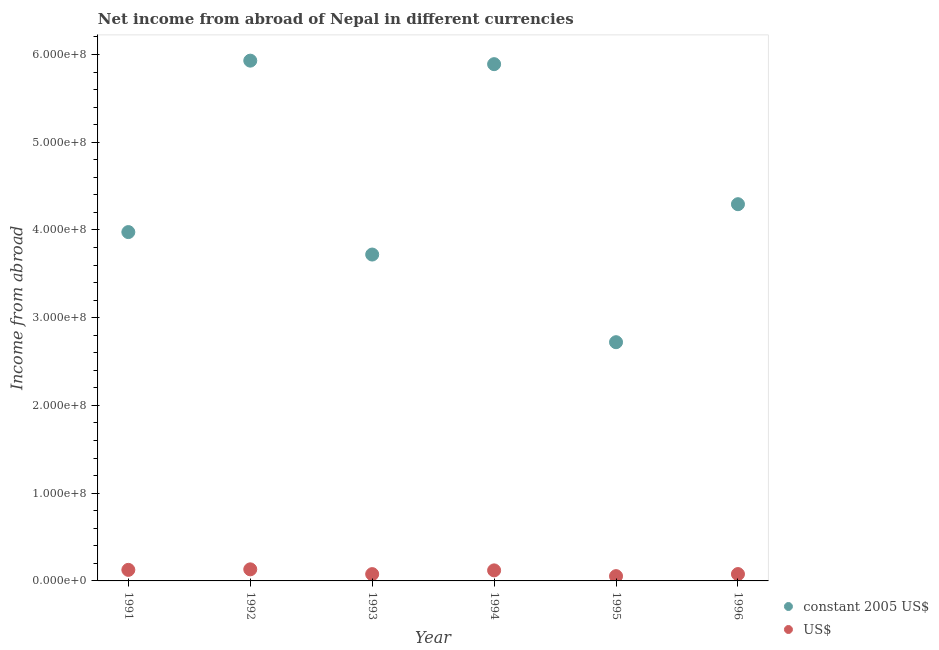How many different coloured dotlines are there?
Offer a terse response. 2. Is the number of dotlines equal to the number of legend labels?
Your response must be concise. Yes. What is the income from abroad in constant 2005 us$ in 1991?
Provide a short and direct response. 3.98e+08. Across all years, what is the maximum income from abroad in us$?
Provide a short and direct response. 1.32e+07. Across all years, what is the minimum income from abroad in constant 2005 us$?
Your response must be concise. 2.72e+08. In which year was the income from abroad in constant 2005 us$ maximum?
Keep it short and to the point. 1992. In which year was the income from abroad in constant 2005 us$ minimum?
Your answer should be compact. 1995. What is the total income from abroad in constant 2005 us$ in the graph?
Provide a succinct answer. 2.65e+09. What is the difference between the income from abroad in us$ in 1991 and that in 1992?
Offer a very short reply. -6.13e+05. What is the difference between the income from abroad in constant 2005 us$ in 1992 and the income from abroad in us$ in 1991?
Offer a terse response. 5.80e+08. What is the average income from abroad in constant 2005 us$ per year?
Keep it short and to the point. 4.42e+08. In the year 1996, what is the difference between the income from abroad in us$ and income from abroad in constant 2005 us$?
Ensure brevity in your answer.  -4.22e+08. In how many years, is the income from abroad in us$ greater than 600000000 units?
Your response must be concise. 0. What is the ratio of the income from abroad in us$ in 1992 to that in 1994?
Your response must be concise. 1.1. Is the income from abroad in us$ in 1993 less than that in 1995?
Give a very brief answer. No. Is the difference between the income from abroad in constant 2005 us$ in 1992 and 1996 greater than the difference between the income from abroad in us$ in 1992 and 1996?
Provide a short and direct response. Yes. What is the difference between the highest and the lowest income from abroad in constant 2005 us$?
Provide a short and direct response. 3.21e+08. Is the income from abroad in us$ strictly greater than the income from abroad in constant 2005 us$ over the years?
Your answer should be compact. No. Is the income from abroad in constant 2005 us$ strictly less than the income from abroad in us$ over the years?
Make the answer very short. No. Does the graph contain grids?
Your answer should be compact. No. How many legend labels are there?
Offer a very short reply. 2. What is the title of the graph?
Ensure brevity in your answer.  Net income from abroad of Nepal in different currencies. Does "Males" appear as one of the legend labels in the graph?
Your answer should be very brief. No. What is the label or title of the Y-axis?
Your answer should be very brief. Income from abroad. What is the Income from abroad of constant 2005 US$ in 1991?
Provide a short and direct response. 3.98e+08. What is the Income from abroad of US$ in 1991?
Make the answer very short. 1.26e+07. What is the Income from abroad of constant 2005 US$ in 1992?
Provide a short and direct response. 5.93e+08. What is the Income from abroad of US$ in 1992?
Your answer should be very brief. 1.32e+07. What is the Income from abroad of constant 2005 US$ in 1993?
Provide a succinct answer. 3.72e+08. What is the Income from abroad of US$ in 1993?
Offer a very short reply. 7.75e+06. What is the Income from abroad in constant 2005 US$ in 1994?
Keep it short and to the point. 5.89e+08. What is the Income from abroad in US$ in 1994?
Offer a terse response. 1.20e+07. What is the Income from abroad of constant 2005 US$ in 1995?
Your answer should be compact. 2.72e+08. What is the Income from abroad of US$ in 1995?
Keep it short and to the point. 5.46e+06. What is the Income from abroad of constant 2005 US$ in 1996?
Give a very brief answer. 4.29e+08. What is the Income from abroad of US$ in 1996?
Provide a short and direct response. 7.80e+06. Across all years, what is the maximum Income from abroad of constant 2005 US$?
Keep it short and to the point. 5.93e+08. Across all years, what is the maximum Income from abroad in US$?
Your answer should be very brief. 1.32e+07. Across all years, what is the minimum Income from abroad of constant 2005 US$?
Your answer should be very brief. 2.72e+08. Across all years, what is the minimum Income from abroad of US$?
Make the answer very short. 5.46e+06. What is the total Income from abroad of constant 2005 US$ in the graph?
Keep it short and to the point. 2.65e+09. What is the total Income from abroad of US$ in the graph?
Make the answer very short. 5.88e+07. What is the difference between the Income from abroad of constant 2005 US$ in 1991 and that in 1992?
Your answer should be very brief. -1.95e+08. What is the difference between the Income from abroad of US$ in 1991 and that in 1992?
Ensure brevity in your answer.  -6.13e+05. What is the difference between the Income from abroad in constant 2005 US$ in 1991 and that in 1993?
Your answer should be compact. 2.56e+07. What is the difference between the Income from abroad in US$ in 1991 and that in 1993?
Make the answer very short. 4.84e+06. What is the difference between the Income from abroad of constant 2005 US$ in 1991 and that in 1994?
Make the answer very short. -1.91e+08. What is the difference between the Income from abroad of US$ in 1991 and that in 1994?
Keep it short and to the point. 5.74e+05. What is the difference between the Income from abroad of constant 2005 US$ in 1991 and that in 1995?
Offer a terse response. 1.26e+08. What is the difference between the Income from abroad in US$ in 1991 and that in 1995?
Provide a succinct answer. 7.13e+06. What is the difference between the Income from abroad of constant 2005 US$ in 1991 and that in 1996?
Give a very brief answer. -3.18e+07. What is the difference between the Income from abroad of US$ in 1991 and that in 1996?
Give a very brief answer. 4.79e+06. What is the difference between the Income from abroad of constant 2005 US$ in 1992 and that in 1993?
Provide a succinct answer. 2.21e+08. What is the difference between the Income from abroad of US$ in 1992 and that in 1993?
Keep it short and to the point. 5.46e+06. What is the difference between the Income from abroad in US$ in 1992 and that in 1994?
Your answer should be compact. 1.19e+06. What is the difference between the Income from abroad in constant 2005 US$ in 1992 and that in 1995?
Make the answer very short. 3.21e+08. What is the difference between the Income from abroad of US$ in 1992 and that in 1995?
Ensure brevity in your answer.  7.74e+06. What is the difference between the Income from abroad in constant 2005 US$ in 1992 and that in 1996?
Your response must be concise. 1.64e+08. What is the difference between the Income from abroad of US$ in 1992 and that in 1996?
Offer a terse response. 5.41e+06. What is the difference between the Income from abroad of constant 2005 US$ in 1993 and that in 1994?
Make the answer very short. -2.17e+08. What is the difference between the Income from abroad in US$ in 1993 and that in 1994?
Make the answer very short. -4.27e+06. What is the difference between the Income from abroad in constant 2005 US$ in 1993 and that in 1995?
Your response must be concise. 9.99e+07. What is the difference between the Income from abroad in US$ in 1993 and that in 1995?
Provide a short and direct response. 2.29e+06. What is the difference between the Income from abroad of constant 2005 US$ in 1993 and that in 1996?
Provide a succinct answer. -5.74e+07. What is the difference between the Income from abroad in constant 2005 US$ in 1994 and that in 1995?
Your answer should be very brief. 3.17e+08. What is the difference between the Income from abroad of US$ in 1994 and that in 1995?
Ensure brevity in your answer.  6.56e+06. What is the difference between the Income from abroad of constant 2005 US$ in 1994 and that in 1996?
Offer a very short reply. 1.60e+08. What is the difference between the Income from abroad of US$ in 1994 and that in 1996?
Your response must be concise. 4.22e+06. What is the difference between the Income from abroad of constant 2005 US$ in 1995 and that in 1996?
Your answer should be compact. -1.57e+08. What is the difference between the Income from abroad in US$ in 1995 and that in 1996?
Keep it short and to the point. -2.34e+06. What is the difference between the Income from abroad in constant 2005 US$ in 1991 and the Income from abroad in US$ in 1992?
Ensure brevity in your answer.  3.84e+08. What is the difference between the Income from abroad of constant 2005 US$ in 1991 and the Income from abroad of US$ in 1993?
Provide a short and direct response. 3.90e+08. What is the difference between the Income from abroad in constant 2005 US$ in 1991 and the Income from abroad in US$ in 1994?
Ensure brevity in your answer.  3.86e+08. What is the difference between the Income from abroad in constant 2005 US$ in 1991 and the Income from abroad in US$ in 1995?
Provide a short and direct response. 3.92e+08. What is the difference between the Income from abroad in constant 2005 US$ in 1991 and the Income from abroad in US$ in 1996?
Provide a short and direct response. 3.90e+08. What is the difference between the Income from abroad in constant 2005 US$ in 1992 and the Income from abroad in US$ in 1993?
Make the answer very short. 5.85e+08. What is the difference between the Income from abroad in constant 2005 US$ in 1992 and the Income from abroad in US$ in 1994?
Your response must be concise. 5.81e+08. What is the difference between the Income from abroad of constant 2005 US$ in 1992 and the Income from abroad of US$ in 1995?
Your answer should be very brief. 5.88e+08. What is the difference between the Income from abroad of constant 2005 US$ in 1992 and the Income from abroad of US$ in 1996?
Your answer should be compact. 5.85e+08. What is the difference between the Income from abroad in constant 2005 US$ in 1993 and the Income from abroad in US$ in 1994?
Your response must be concise. 3.60e+08. What is the difference between the Income from abroad in constant 2005 US$ in 1993 and the Income from abroad in US$ in 1995?
Provide a short and direct response. 3.67e+08. What is the difference between the Income from abroad of constant 2005 US$ in 1993 and the Income from abroad of US$ in 1996?
Your answer should be very brief. 3.64e+08. What is the difference between the Income from abroad of constant 2005 US$ in 1994 and the Income from abroad of US$ in 1995?
Make the answer very short. 5.84e+08. What is the difference between the Income from abroad of constant 2005 US$ in 1994 and the Income from abroad of US$ in 1996?
Offer a very short reply. 5.81e+08. What is the difference between the Income from abroad of constant 2005 US$ in 1995 and the Income from abroad of US$ in 1996?
Provide a short and direct response. 2.64e+08. What is the average Income from abroad in constant 2005 US$ per year?
Offer a terse response. 4.42e+08. What is the average Income from abroad in US$ per year?
Give a very brief answer. 9.81e+06. In the year 1991, what is the difference between the Income from abroad in constant 2005 US$ and Income from abroad in US$?
Offer a very short reply. 3.85e+08. In the year 1992, what is the difference between the Income from abroad in constant 2005 US$ and Income from abroad in US$?
Offer a very short reply. 5.80e+08. In the year 1993, what is the difference between the Income from abroad in constant 2005 US$ and Income from abroad in US$?
Your answer should be compact. 3.64e+08. In the year 1994, what is the difference between the Income from abroad in constant 2005 US$ and Income from abroad in US$?
Your answer should be very brief. 5.77e+08. In the year 1995, what is the difference between the Income from abroad in constant 2005 US$ and Income from abroad in US$?
Your answer should be compact. 2.67e+08. In the year 1996, what is the difference between the Income from abroad in constant 2005 US$ and Income from abroad in US$?
Your response must be concise. 4.22e+08. What is the ratio of the Income from abroad in constant 2005 US$ in 1991 to that in 1992?
Ensure brevity in your answer.  0.67. What is the ratio of the Income from abroad of US$ in 1991 to that in 1992?
Ensure brevity in your answer.  0.95. What is the ratio of the Income from abroad of constant 2005 US$ in 1991 to that in 1993?
Keep it short and to the point. 1.07. What is the ratio of the Income from abroad in US$ in 1991 to that in 1993?
Ensure brevity in your answer.  1.63. What is the ratio of the Income from abroad of constant 2005 US$ in 1991 to that in 1994?
Offer a very short reply. 0.68. What is the ratio of the Income from abroad in US$ in 1991 to that in 1994?
Give a very brief answer. 1.05. What is the ratio of the Income from abroad of constant 2005 US$ in 1991 to that in 1995?
Keep it short and to the point. 1.46. What is the ratio of the Income from abroad of US$ in 1991 to that in 1995?
Make the answer very short. 2.31. What is the ratio of the Income from abroad in constant 2005 US$ in 1991 to that in 1996?
Provide a succinct answer. 0.93. What is the ratio of the Income from abroad in US$ in 1991 to that in 1996?
Keep it short and to the point. 1.61. What is the ratio of the Income from abroad of constant 2005 US$ in 1992 to that in 1993?
Keep it short and to the point. 1.59. What is the ratio of the Income from abroad in US$ in 1992 to that in 1993?
Your response must be concise. 1.7. What is the ratio of the Income from abroad of constant 2005 US$ in 1992 to that in 1994?
Offer a very short reply. 1.01. What is the ratio of the Income from abroad in US$ in 1992 to that in 1994?
Offer a very short reply. 1.1. What is the ratio of the Income from abroad in constant 2005 US$ in 1992 to that in 1995?
Provide a short and direct response. 2.18. What is the ratio of the Income from abroad in US$ in 1992 to that in 1995?
Ensure brevity in your answer.  2.42. What is the ratio of the Income from abroad of constant 2005 US$ in 1992 to that in 1996?
Provide a succinct answer. 1.38. What is the ratio of the Income from abroad in US$ in 1992 to that in 1996?
Keep it short and to the point. 1.69. What is the ratio of the Income from abroad in constant 2005 US$ in 1993 to that in 1994?
Offer a terse response. 0.63. What is the ratio of the Income from abroad in US$ in 1993 to that in 1994?
Your answer should be very brief. 0.64. What is the ratio of the Income from abroad of constant 2005 US$ in 1993 to that in 1995?
Provide a short and direct response. 1.37. What is the ratio of the Income from abroad of US$ in 1993 to that in 1995?
Your answer should be compact. 1.42. What is the ratio of the Income from abroad in constant 2005 US$ in 1993 to that in 1996?
Your answer should be compact. 0.87. What is the ratio of the Income from abroad in constant 2005 US$ in 1994 to that in 1995?
Provide a succinct answer. 2.16. What is the ratio of the Income from abroad in constant 2005 US$ in 1994 to that in 1996?
Offer a terse response. 1.37. What is the ratio of the Income from abroad of US$ in 1994 to that in 1996?
Keep it short and to the point. 1.54. What is the ratio of the Income from abroad of constant 2005 US$ in 1995 to that in 1996?
Offer a very short reply. 0.63. What is the ratio of the Income from abroad of US$ in 1995 to that in 1996?
Your response must be concise. 0.7. What is the difference between the highest and the second highest Income from abroad in US$?
Your answer should be compact. 6.13e+05. What is the difference between the highest and the lowest Income from abroad of constant 2005 US$?
Ensure brevity in your answer.  3.21e+08. What is the difference between the highest and the lowest Income from abroad of US$?
Give a very brief answer. 7.74e+06. 